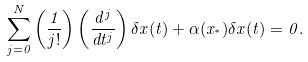<formula> <loc_0><loc_0><loc_500><loc_500>\sum _ { j = 0 } ^ { N } \left ( \frac { 1 } { j ! } \right ) \left ( \frac { d ^ { j } } { d t ^ { j } } \right ) \delta x ( t ) + \alpha ( x _ { ^ { * } } ) \delta x ( t ) = 0 .</formula> 